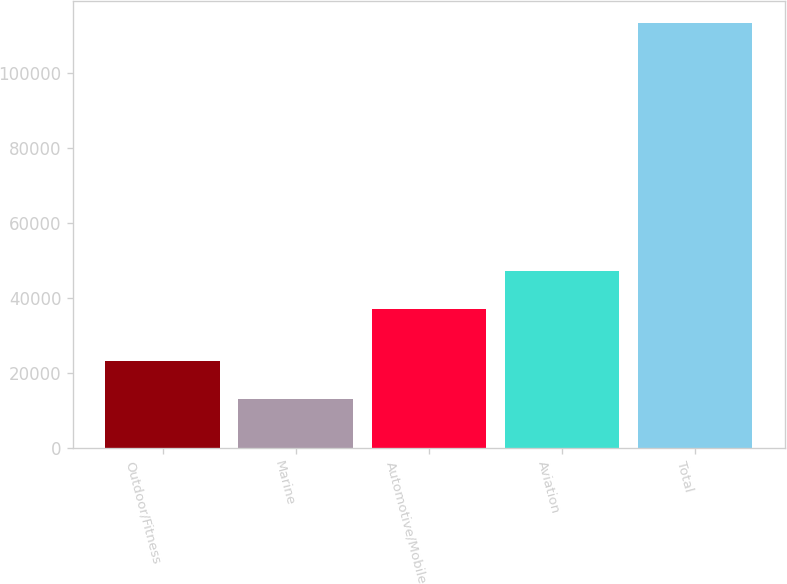Convert chart to OTSL. <chart><loc_0><loc_0><loc_500><loc_500><bar_chart><fcel>Outdoor/Fitness<fcel>Marine<fcel>Automotive/Mobile<fcel>Aviation<fcel>Total<nl><fcel>23140.3<fcel>13121<fcel>37125<fcel>47144.3<fcel>113314<nl></chart> 